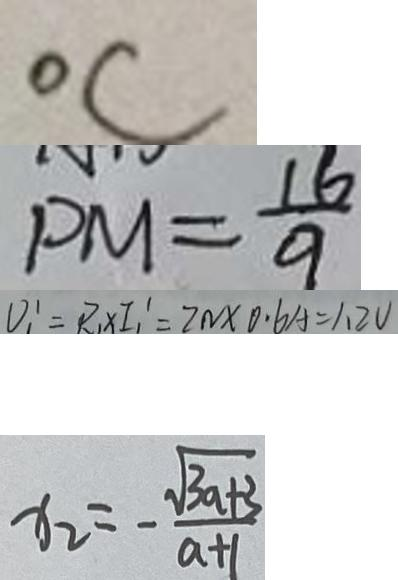Convert formula to latex. <formula><loc_0><loc_0><loc_500><loc_500>^ { \circ } C 
 P M = \frac { 1 6 } { 9 } 
 V _ { 1 } ^ { \prime } = R _ { 1 } \times I _ { 1 } ^ { \prime } = 2 N \times 0 . 6 A = 1 . 2 V 
 x _ { 2 } = - \frac { \sqrt { 3 a + 3 } } { a + 1 }</formula> 